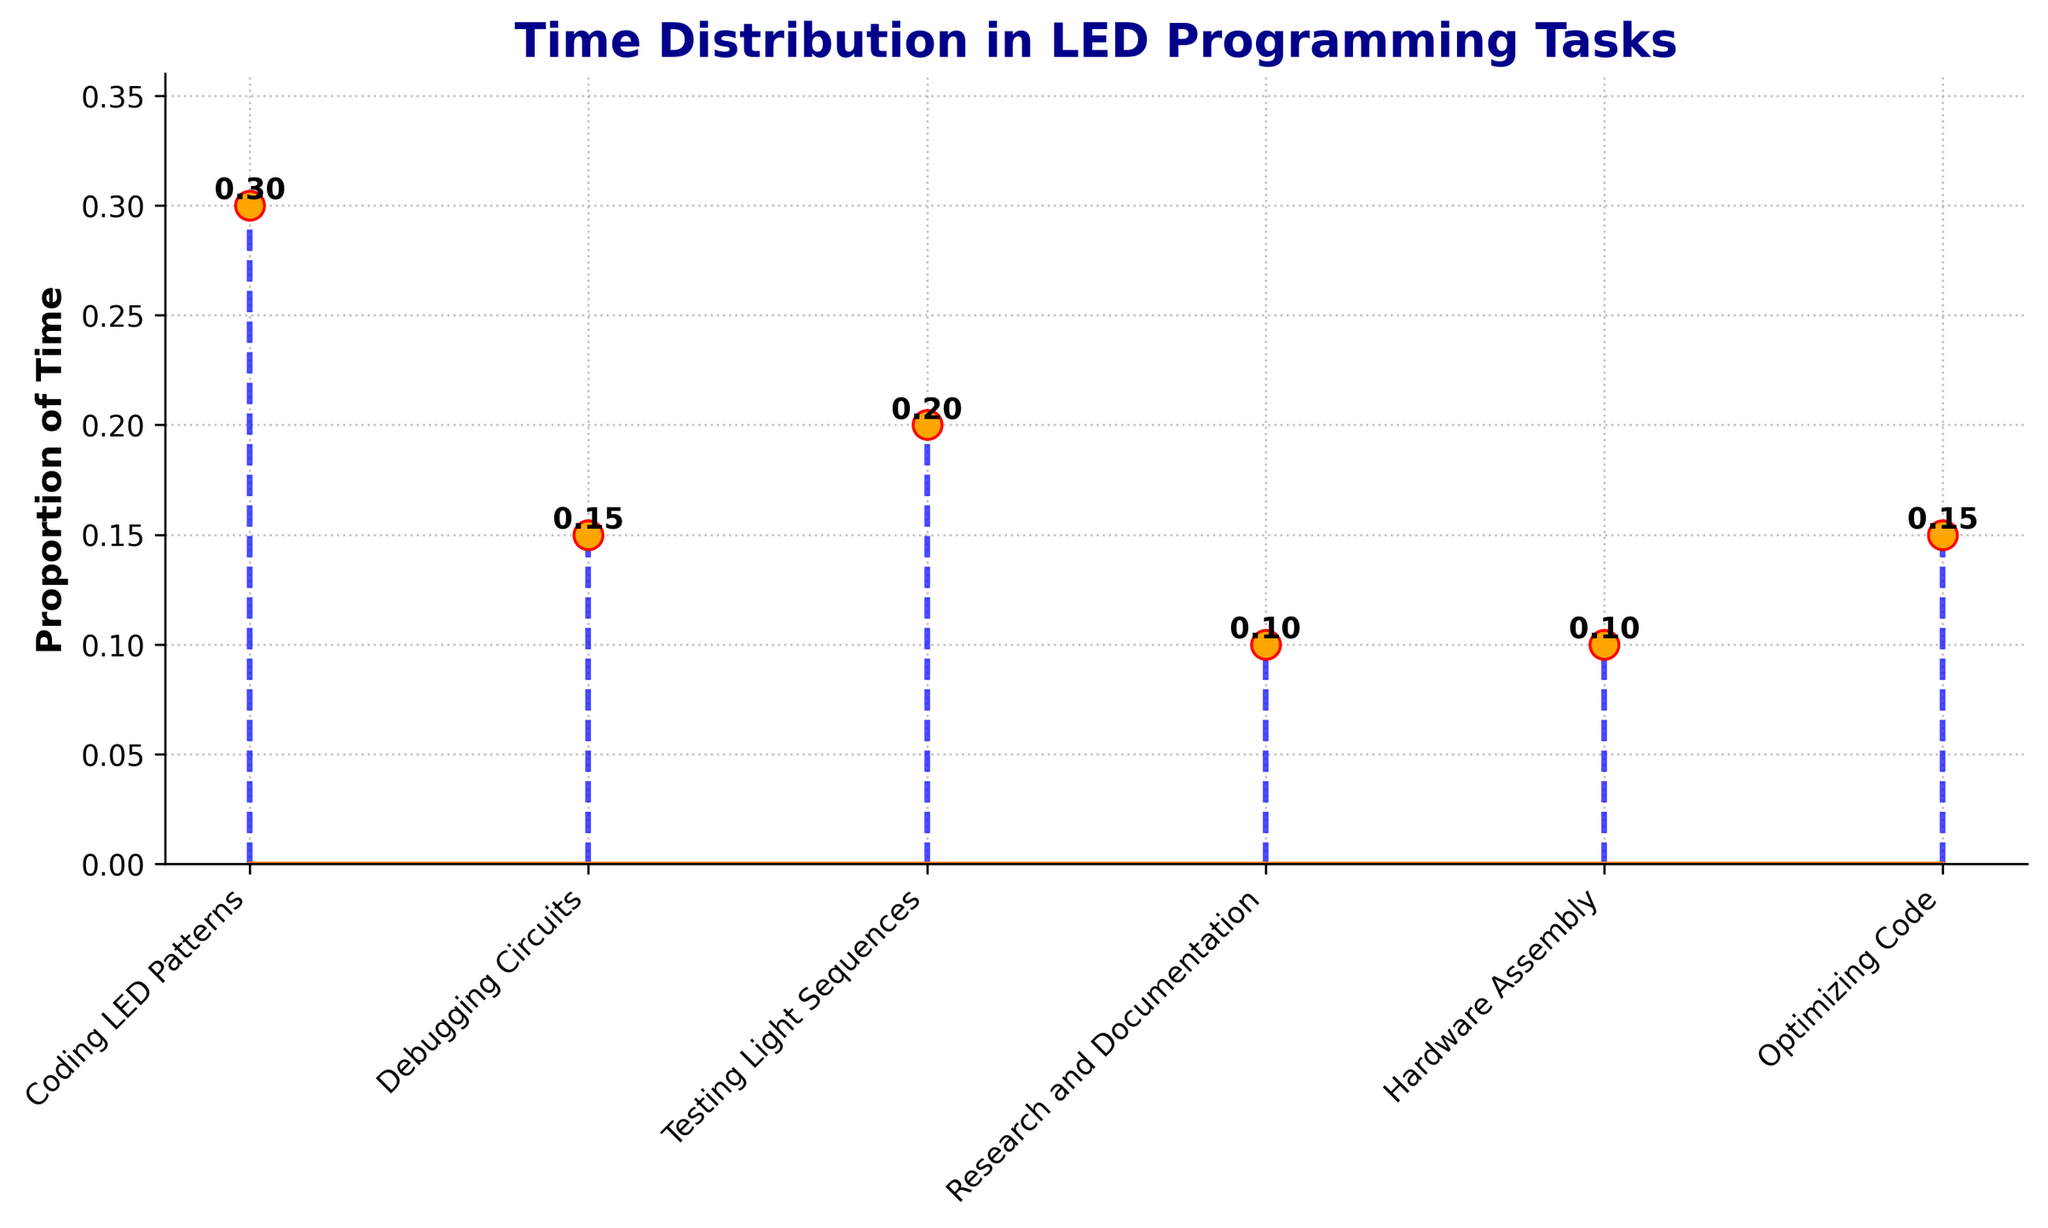What's the title of the plot? The title of the plot is prominently displayed at the top and reads "Time Distribution in LED Programming Tasks".
Answer: Time Distribution in LED Programming Tasks Which task takes the most time? By comparing the heights of the markers for each task, "Coding LED Patterns" has the tallest stem, indicating it takes the most time.
Answer: Coding LED Patterns What's the proportion of time spent on Debugging Circuits? The proportion on the y-axis corresponding to "Debugging Circuits" is labeled, and it reads 0.15.
Answer: 0.15 How is the overall grid pattern in the plot designed? The plot has a grid pattern with dotted lines (:) and a slight transparency (alpha = 0.7), making it easy to see without overshadowing the data.
Answer: Dotted lines with slight transparency What's the sum of the proportions for Debugging Circuits and Optimizing Code? Adding the proportions for "Debugging Circuits" (0.15) and "Optimizing Code" (0.15) gives a sum of 0.15 + 0.15.
Answer: 0.3 Which task has an equal proportion of time compared to Research and Documentation? Both "Research and Documentation" and "Hardware Assembly" have the same proportion of 0.10, as indicated on the y-axis.
Answer: Hardware Assembly What's the difference in time proportion between Coding LED Patterns and Testing Light Sequences? The proportion for "Coding LED Patterns" is 0.30 and for "Testing Light Sequences" it is 0.20. Subtracting these gives 0.30 - 0.20.
Answer: 0.10 Which marker color is used for the stem lines? The color of the stem lines in the plot is blue, making it visually distinct.
Answer: Blue How many tasks spend less than 0.2 proportion of time? The tasks with proportions below 0.2 are: "Debugging Circuits" (0.15), "Research and Documentation" (0.10), "Hardware Assembly" (0.10), and "Optimizing Code" (0.15). Counting these tasks gives four.
Answer: Four Which task spends more time: Testing Light Sequences or Hardware Assembly? Comparing the y-axis values, "Testing Light Sequences" (0.20) exceeds "Hardware Assembly" (0.10).
Answer: Testing Light Sequences 